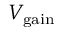Convert formula to latex. <formula><loc_0><loc_0><loc_500><loc_500>V _ { g a i n }</formula> 